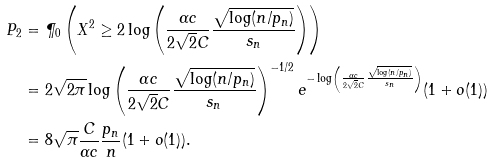<formula> <loc_0><loc_0><loc_500><loc_500>P _ { 2 } & = \P _ { 0 } \left ( X ^ { 2 } \geq 2 \log \left ( \frac { \alpha c } { 2 \sqrt { 2 } C } \frac { \sqrt { \log ( n / p _ { n } ) } } { s _ { n } } \right ) \right ) \\ & = 2 \sqrt { 2 \pi } \log \left ( \frac { \alpha c } { 2 \sqrt { 2 } C } \frac { \sqrt { \log ( n / p _ { n } ) } } { s _ { n } } \right ) ^ { - 1 / 2 } e ^ { - \log \left ( \frac { \alpha c } { 2 \sqrt { 2 } C } \frac { \sqrt { \log ( n / p _ { n } ) } } { s _ { n } } \right ) } ( 1 + o ( 1 ) ) \\ & = 8 \sqrt { \pi } \frac { C } { \alpha c } \frac { p _ { n } } { n } ( 1 + o ( 1 ) ) .</formula> 